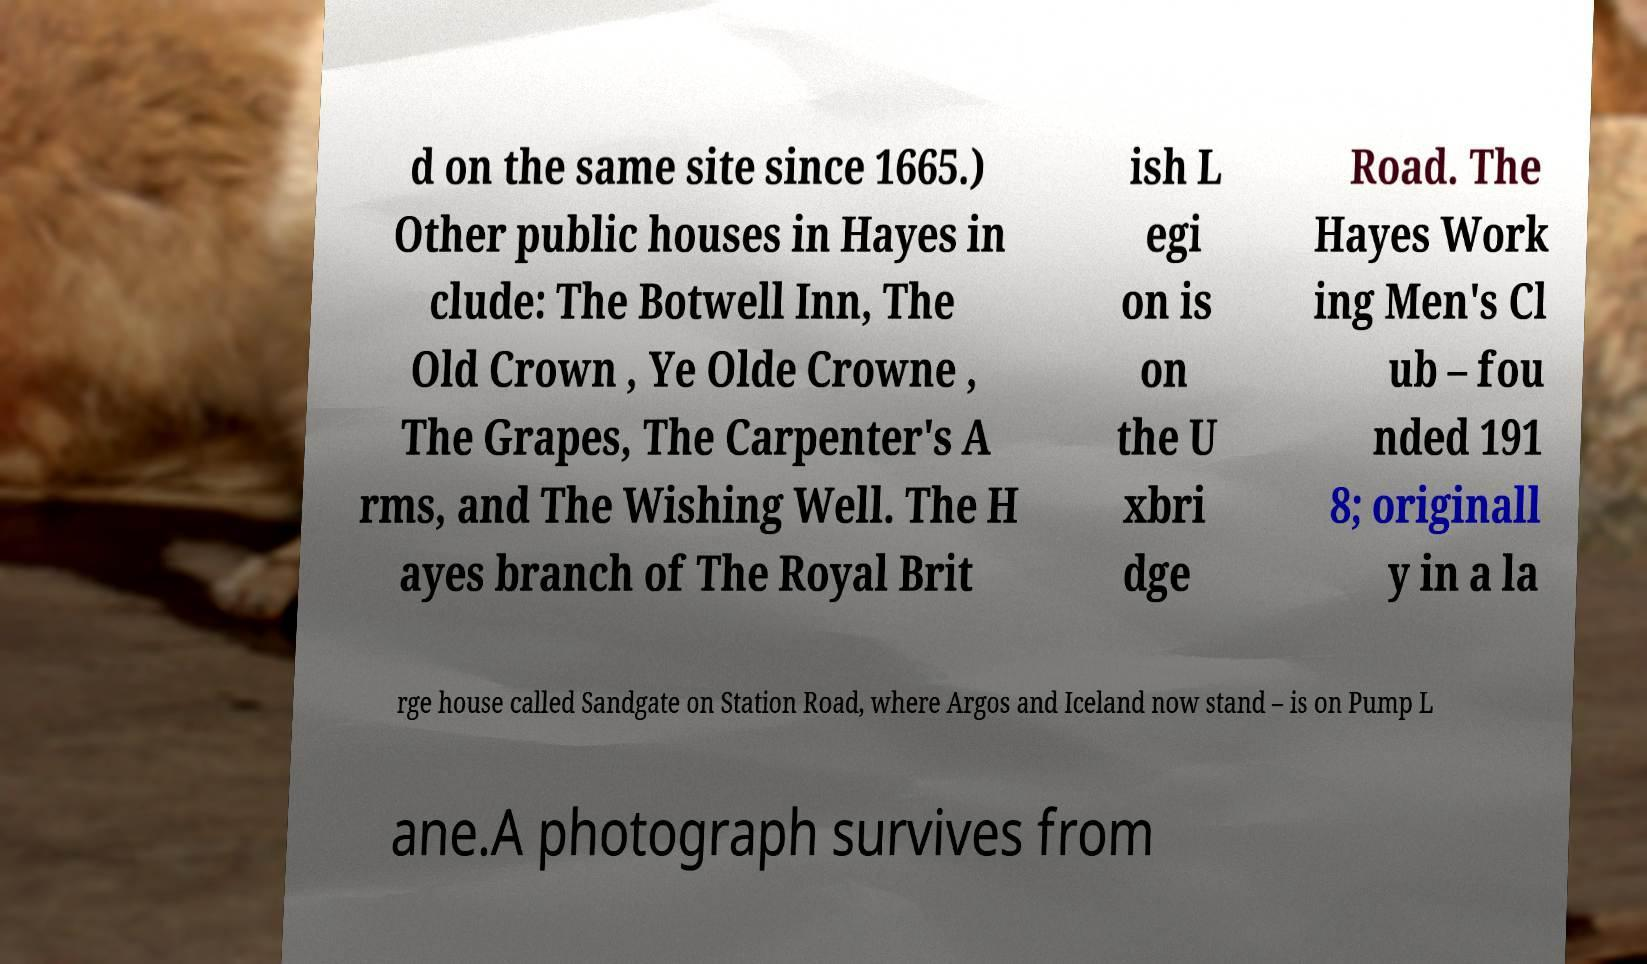Please read and relay the text visible in this image. What does it say? d on the same site since 1665.) Other public houses in Hayes in clude: The Botwell Inn, The Old Crown , Ye Olde Crowne , The Grapes, The Carpenter's A rms, and The Wishing Well. The H ayes branch of The Royal Brit ish L egi on is on the U xbri dge Road. The Hayes Work ing Men's Cl ub – fou nded 191 8; originall y in a la rge house called Sandgate on Station Road, where Argos and Iceland now stand – is on Pump L ane.A photograph survives from 